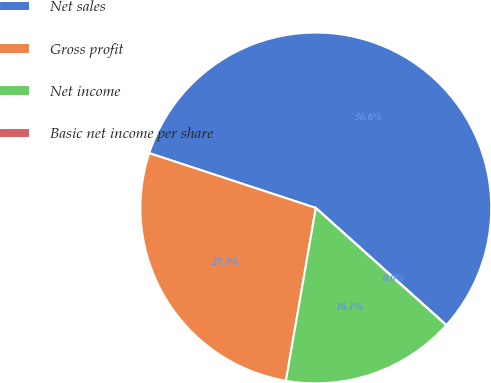<chart> <loc_0><loc_0><loc_500><loc_500><pie_chart><fcel>Net sales<fcel>Gross profit<fcel>Net income<fcel>Basic net income per share<nl><fcel>56.58%<fcel>27.33%<fcel>16.08%<fcel>0.0%<nl></chart> 